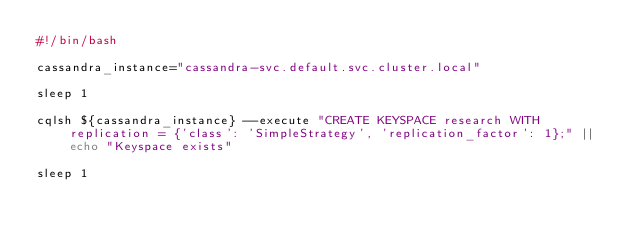<code> <loc_0><loc_0><loc_500><loc_500><_Bash_>#!/bin/bash

cassandra_instance="cassandra-svc.default.svc.cluster.local"

sleep 1

cqlsh ${cassandra_instance} --execute "CREATE KEYSPACE research WITH replication = {'class': 'SimpleStrategy', 'replication_factor': 1};" || echo "Keyspace exists"

sleep 1
</code> 